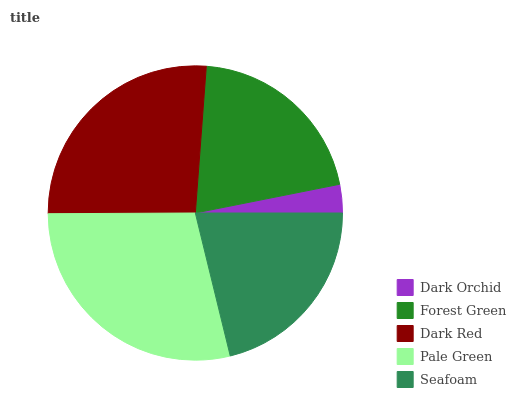Is Dark Orchid the minimum?
Answer yes or no. Yes. Is Pale Green the maximum?
Answer yes or no. Yes. Is Forest Green the minimum?
Answer yes or no. No. Is Forest Green the maximum?
Answer yes or no. No. Is Forest Green greater than Dark Orchid?
Answer yes or no. Yes. Is Dark Orchid less than Forest Green?
Answer yes or no. Yes. Is Dark Orchid greater than Forest Green?
Answer yes or no. No. Is Forest Green less than Dark Orchid?
Answer yes or no. No. Is Seafoam the high median?
Answer yes or no. Yes. Is Seafoam the low median?
Answer yes or no. Yes. Is Dark Orchid the high median?
Answer yes or no. No. Is Dark Red the low median?
Answer yes or no. No. 